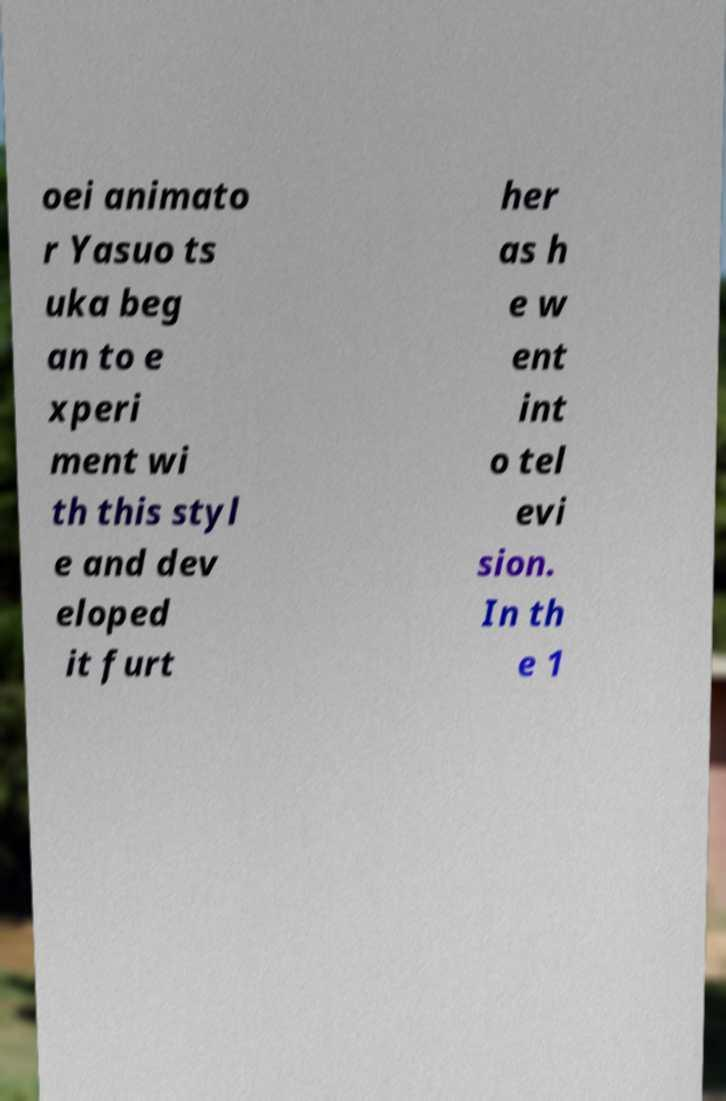Please identify and transcribe the text found in this image. oei animato r Yasuo ts uka beg an to e xperi ment wi th this styl e and dev eloped it furt her as h e w ent int o tel evi sion. In th e 1 